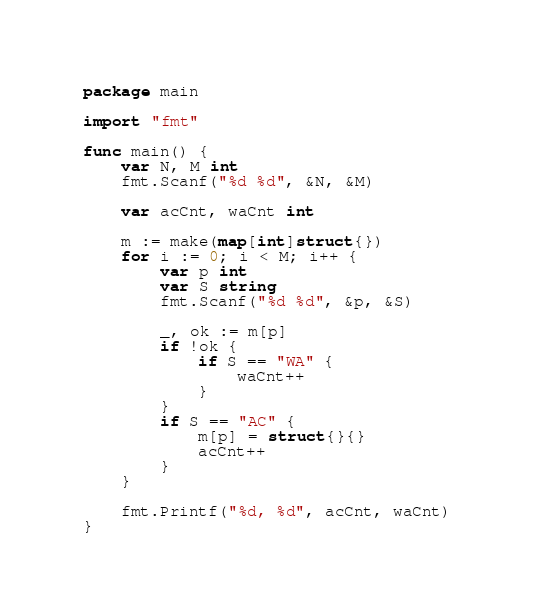Convert code to text. <code><loc_0><loc_0><loc_500><loc_500><_Go_>package main

import "fmt"

func main() {
	var N, M int
	fmt.Scanf("%d %d", &N, &M)

	var acCnt, waCnt int

	m := make(map[int]struct{})
	for i := 0; i < M; i++ {
		var p int
		var S string
		fmt.Scanf("%d %d", &p, &S)

		_, ok := m[p]
		if !ok {
			if S == "WA" {
				waCnt++
			}
		}
		if S == "AC" {
			m[p] = struct{}{}
			acCnt++
		}
	}

	fmt.Printf("%d, %d", acCnt, waCnt)
}
</code> 